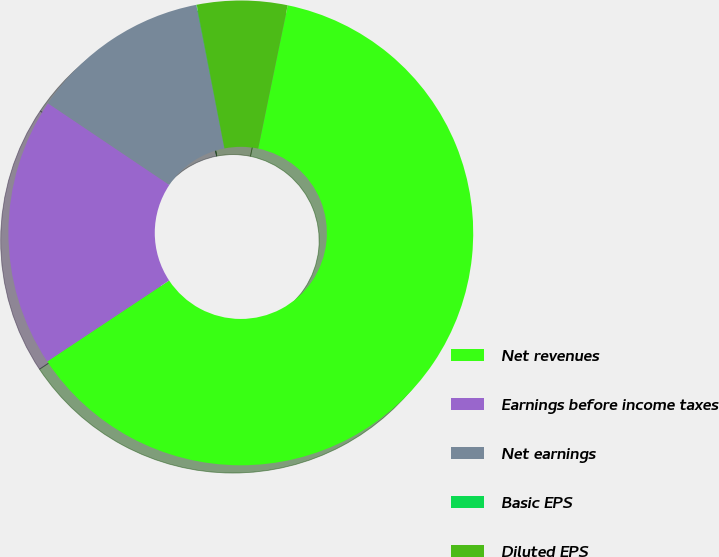Convert chart to OTSL. <chart><loc_0><loc_0><loc_500><loc_500><pie_chart><fcel>Net revenues<fcel>Earnings before income taxes<fcel>Net earnings<fcel>Basic EPS<fcel>Diluted EPS<nl><fcel>62.43%<fcel>18.75%<fcel>12.51%<fcel>0.03%<fcel>6.27%<nl></chart> 